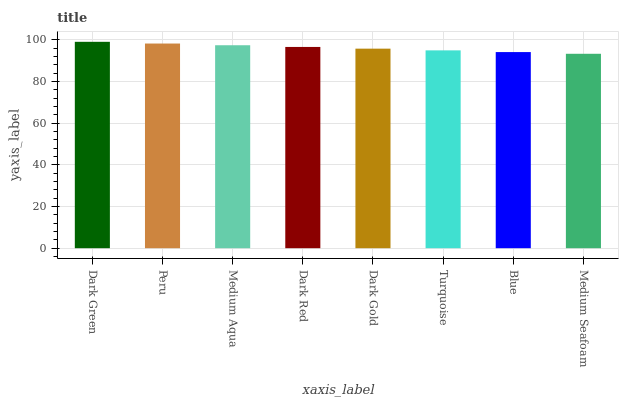Is Medium Seafoam the minimum?
Answer yes or no. Yes. Is Dark Green the maximum?
Answer yes or no. Yes. Is Peru the minimum?
Answer yes or no. No. Is Peru the maximum?
Answer yes or no. No. Is Dark Green greater than Peru?
Answer yes or no. Yes. Is Peru less than Dark Green?
Answer yes or no. Yes. Is Peru greater than Dark Green?
Answer yes or no. No. Is Dark Green less than Peru?
Answer yes or no. No. Is Dark Red the high median?
Answer yes or no. Yes. Is Dark Gold the low median?
Answer yes or no. Yes. Is Dark Gold the high median?
Answer yes or no. No. Is Dark Red the low median?
Answer yes or no. No. 